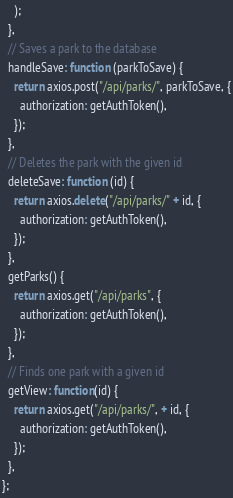Convert code to text. <code><loc_0><loc_0><loc_500><loc_500><_JavaScript_>    );
  },
  // Saves a park to the database
  handleSave: function (parkToSave) {
    return axios.post("/api/parks/", parkToSave, {
      authorization: getAuthToken(),
    });
  },
  // Deletes the park with the given id
  deleteSave: function (id) {
    return axios.delete("/api/parks/" + id, {
      authorization: getAuthToken(),
    });
  },
  getParks() {
    return axios.get("/api/parks", {
      authorization: getAuthToken(),
    });
  },
  // Finds one park with a given id
  getView: function(id) {
    return axios.get("/api/parks/", + id, {
      authorization: getAuthToken(),
    });
  },
};
</code> 